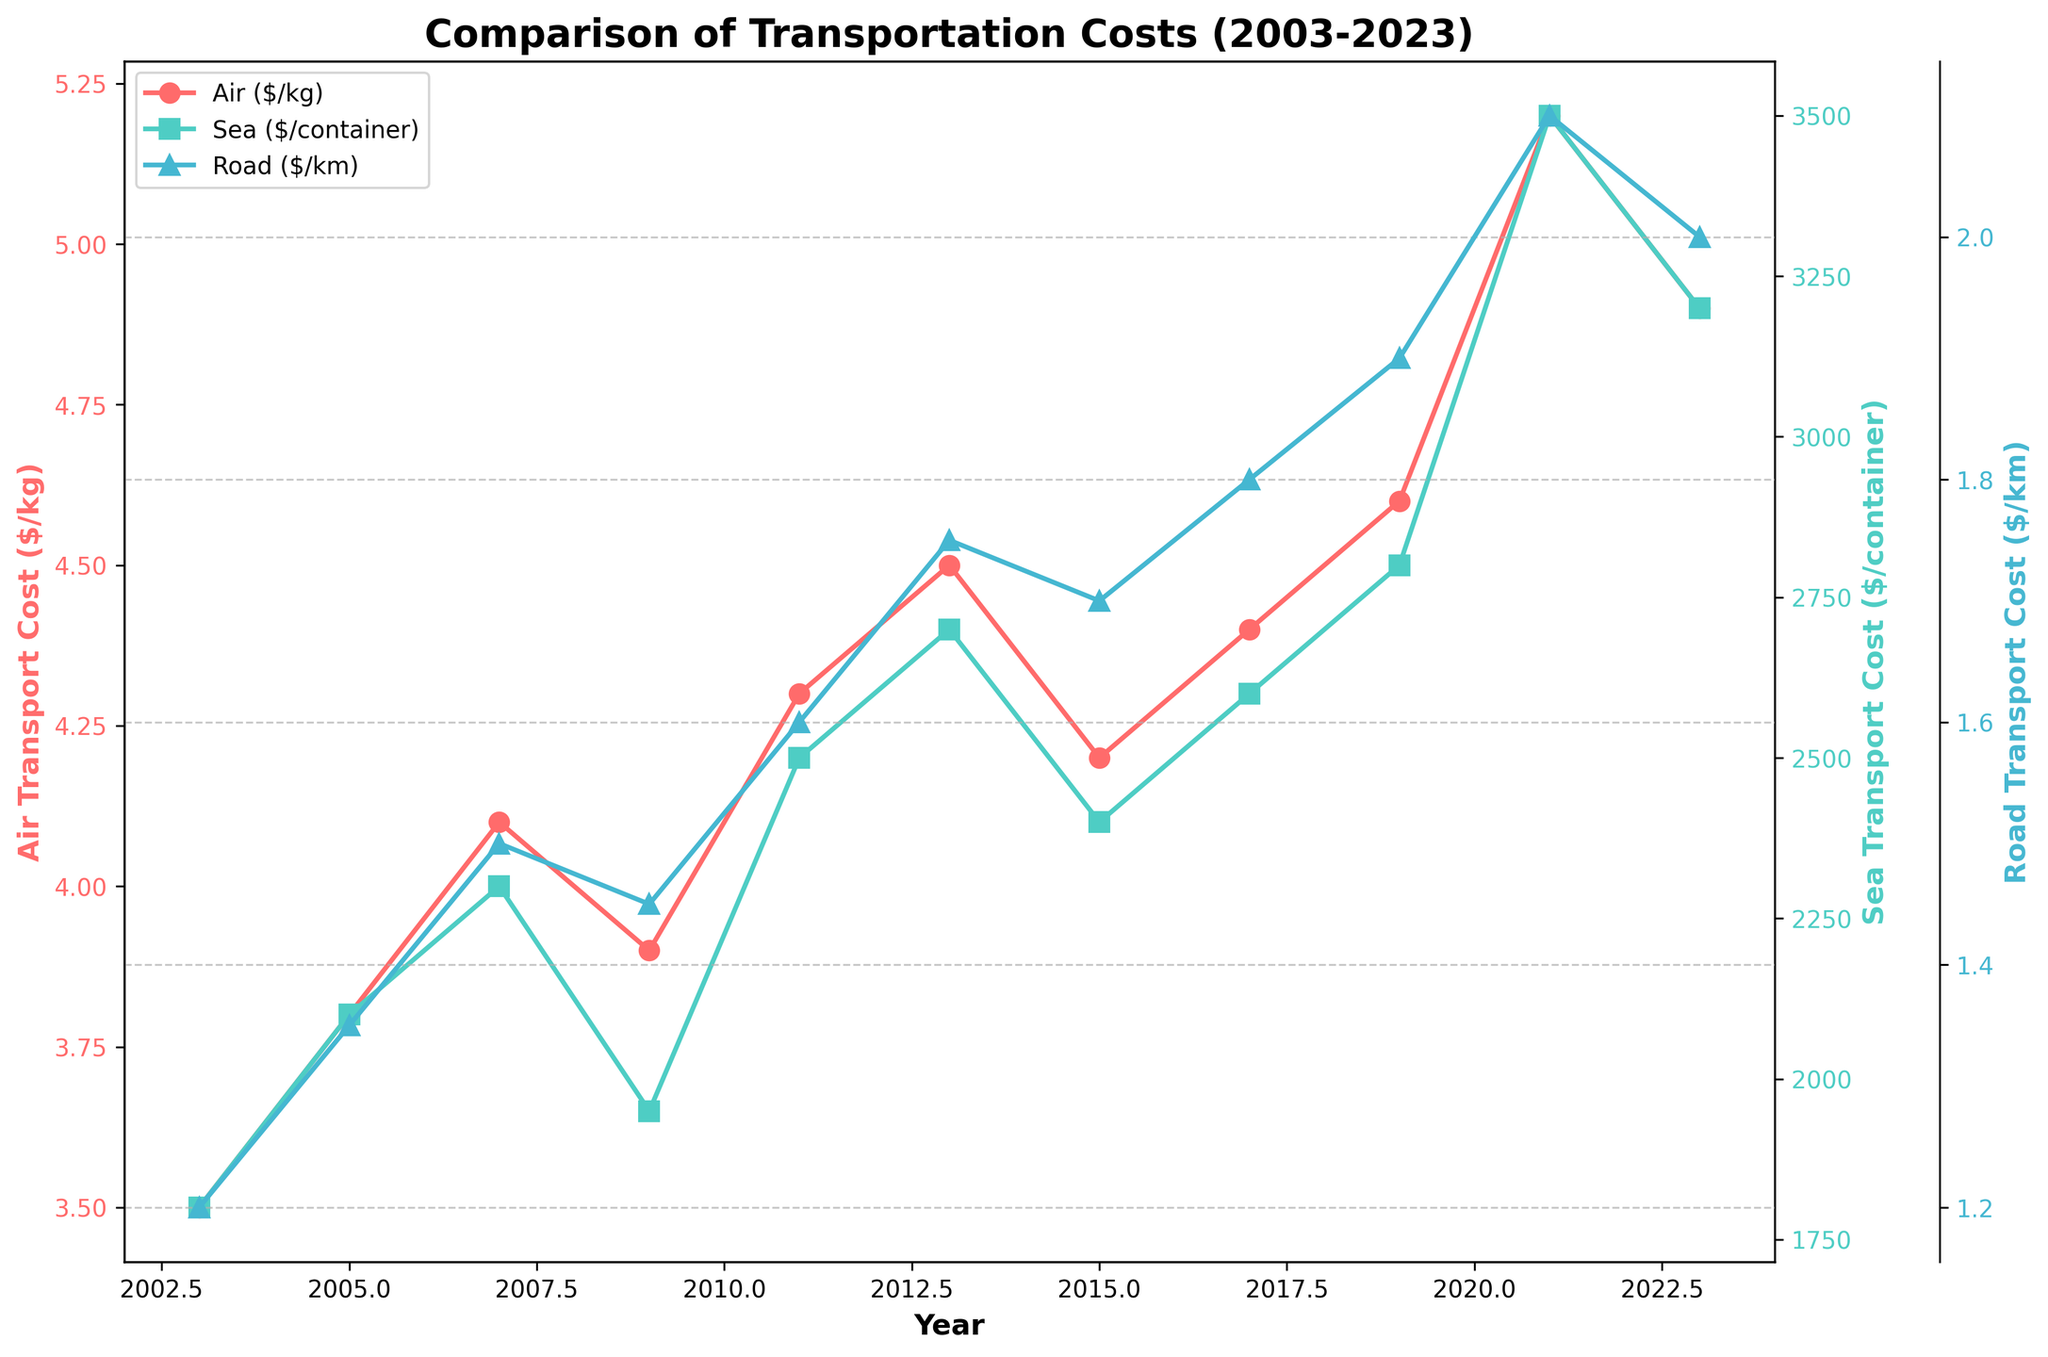What's the transportation mode with the highest increase in cost from 2003 to 2023? To determine the transportation mode with the highest increase, find the difference in cost for each mode between 2003 and 2023. Air increased from $3.50 to $4.90, a difference of $1.40. Sea increased from $1800 to $3200, a difference of $1400. Road increased from $1.20 to $2.00, a difference of $0.80. The sea transport cost increased the most.
Answer: Sea Which year saw the highest cost for air transportation? Examine the air transportation cost values across the years and identify the highest value. The highest cost is $5.20, recorded in 2021.
Answer: 2021 What is the average cost of road transportation over the 20-year period? Sum the road transportation costs for all years and divide by the number of years (11). Total cost is $1.20 + $1.35 + $1.50 + $1.45 + $1.60 + $1.75 + $1.70 + $1.80 + $1.90 + $2.10 + $2.00 = $18.35. Divide this by 11: $18.35/11 ≈ $1.67.
Answer: $1.67 Which transportation mode had the least variability in costs over the period? Measure the range for each mode by subtracting the minimum value from the maximum value. Air's range: $5.20 - $3.50 = $1.70. Sea's range: $3500 - $1800 = $1700. Road's range: $2.10 - $1.20 = $0.90. Road transportation had the least variability.
Answer: Road What were the transportation costs for all modes in 2009? Locate the 2009 values: Air was $3.90, Sea was $1950, Road was $1.45.
Answer: Air: $3.90, Sea: $1950, Road: $1.45 By how much did sea transportation costs increase from 2011 to 2021? Subtract the 2011 sea cost from the 2021 sea cost: $3500 - $2500 = $1000.
Answer: $1000 How many times did the air transport cost change its trend (increase or decrease) over the 20 years? Analyzing the trend over the years: 2003-2005 (up), 2005-2007 (up), 2007-2009 (down), 2009-2011 (up), 2011-2013 (up), 2013-2015 (down), 2015-2017 (up), 2017-2019 (up), 2019-2021 (up), 2021-2023 (down). There were 3 downward trends and 6 upward trends, each change counts as a trend shift: 9 trend shifts.
Answer: 9 In which years were the costs of road transportation higher than those of air transportation? Compare road and air transport costs year by year and identify the years where road costs exceed air costs. None of the years show road transportation costs higher than air transportation costs.
Answer: None 